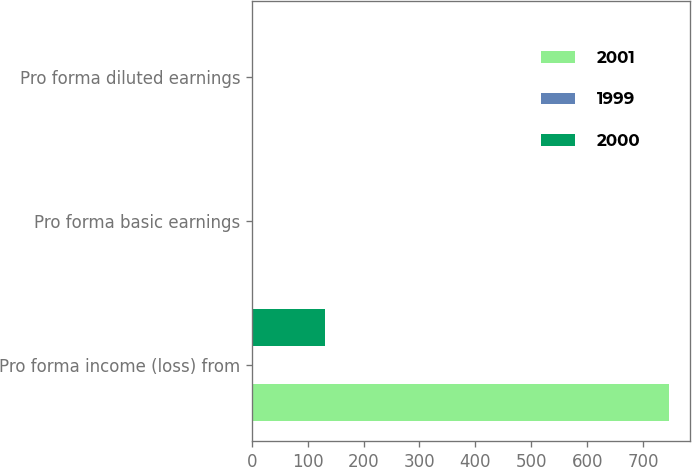Convert chart to OTSL. <chart><loc_0><loc_0><loc_500><loc_500><stacked_bar_chart><ecel><fcel>Pro forma income (loss) from<fcel>Pro forma basic earnings<fcel>Pro forma diluted earnings<nl><fcel>2001<fcel>746.9<fcel>1.26<fcel>1.26<nl><fcel>1999<fcel>1.81<fcel>2.52<fcel>2.36<nl><fcel>2000<fcel>131.3<fcel>0.25<fcel>0.25<nl></chart> 